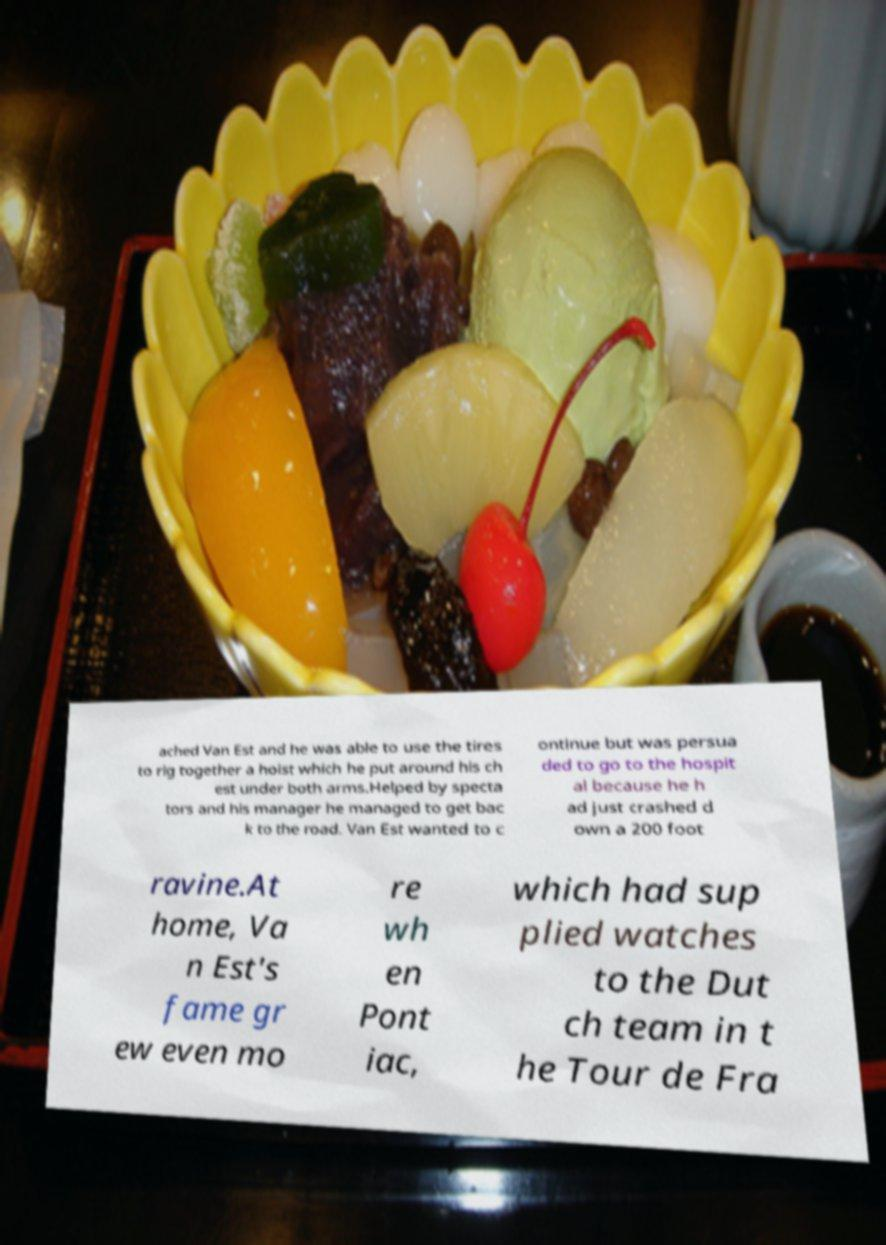What messages or text are displayed in this image? I need them in a readable, typed format. ached Van Est and he was able to use the tires to rig together a hoist which he put around his ch est under both arms.Helped by specta tors and his manager he managed to get bac k to the road. Van Est wanted to c ontinue but was persua ded to go to the hospit al because he h ad just crashed d own a 200 foot ravine.At home, Va n Est's fame gr ew even mo re wh en Pont iac, which had sup plied watches to the Dut ch team in t he Tour de Fra 